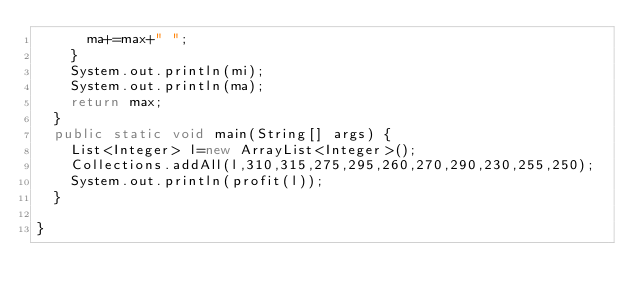Convert code to text. <code><loc_0><loc_0><loc_500><loc_500><_Java_>			ma+=max+" ";
		}
		System.out.println(mi);
		System.out.println(ma);
		return max;
	}
	public static void main(String[] args) {
		List<Integer> l=new ArrayList<Integer>();
		Collections.addAll(l,310,315,275,295,260,270,290,230,255,250);
		System.out.println(profit(l));
	}

}
</code> 